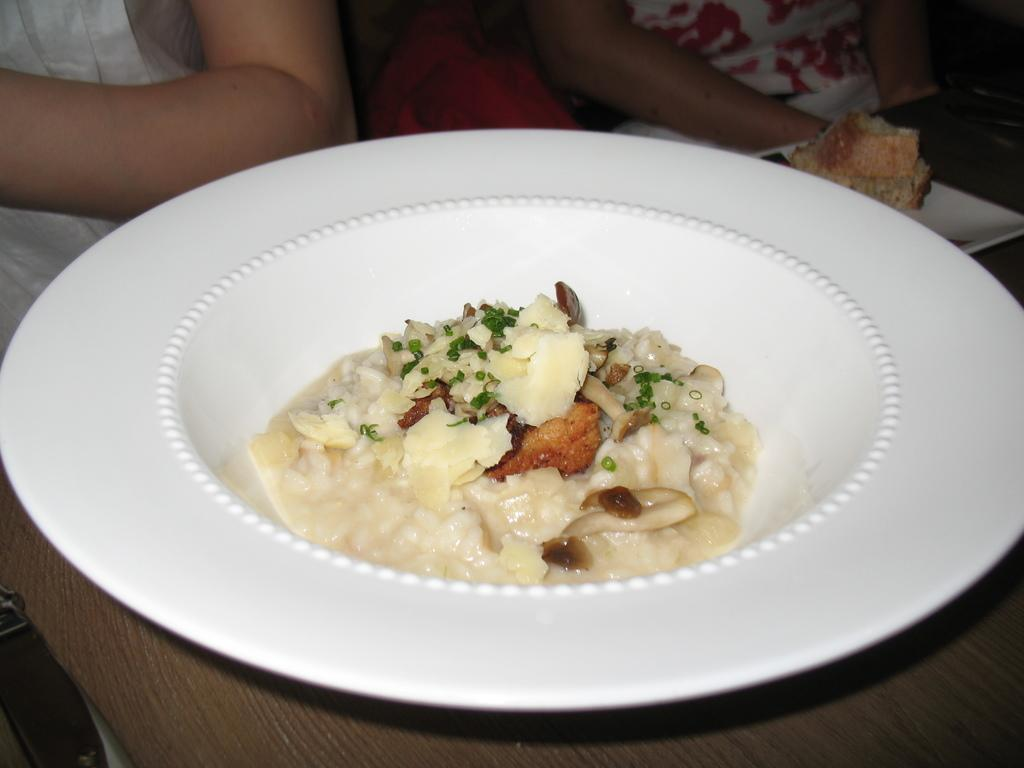What type of food can be seen in the image? The food in the image is in brown and cream colors. How is the food presented in the image? The food is on a plate in the image. What color is the plate? The plate is white. Can you describe the people in the background of the image? There are two persons sitting in the background of the image. What type of rock can be seen in the image? There is no rock present in the image; it features food on a plate with two persons sitting in the background. Is there any snow visible in the image? There is no snow present in the image. 